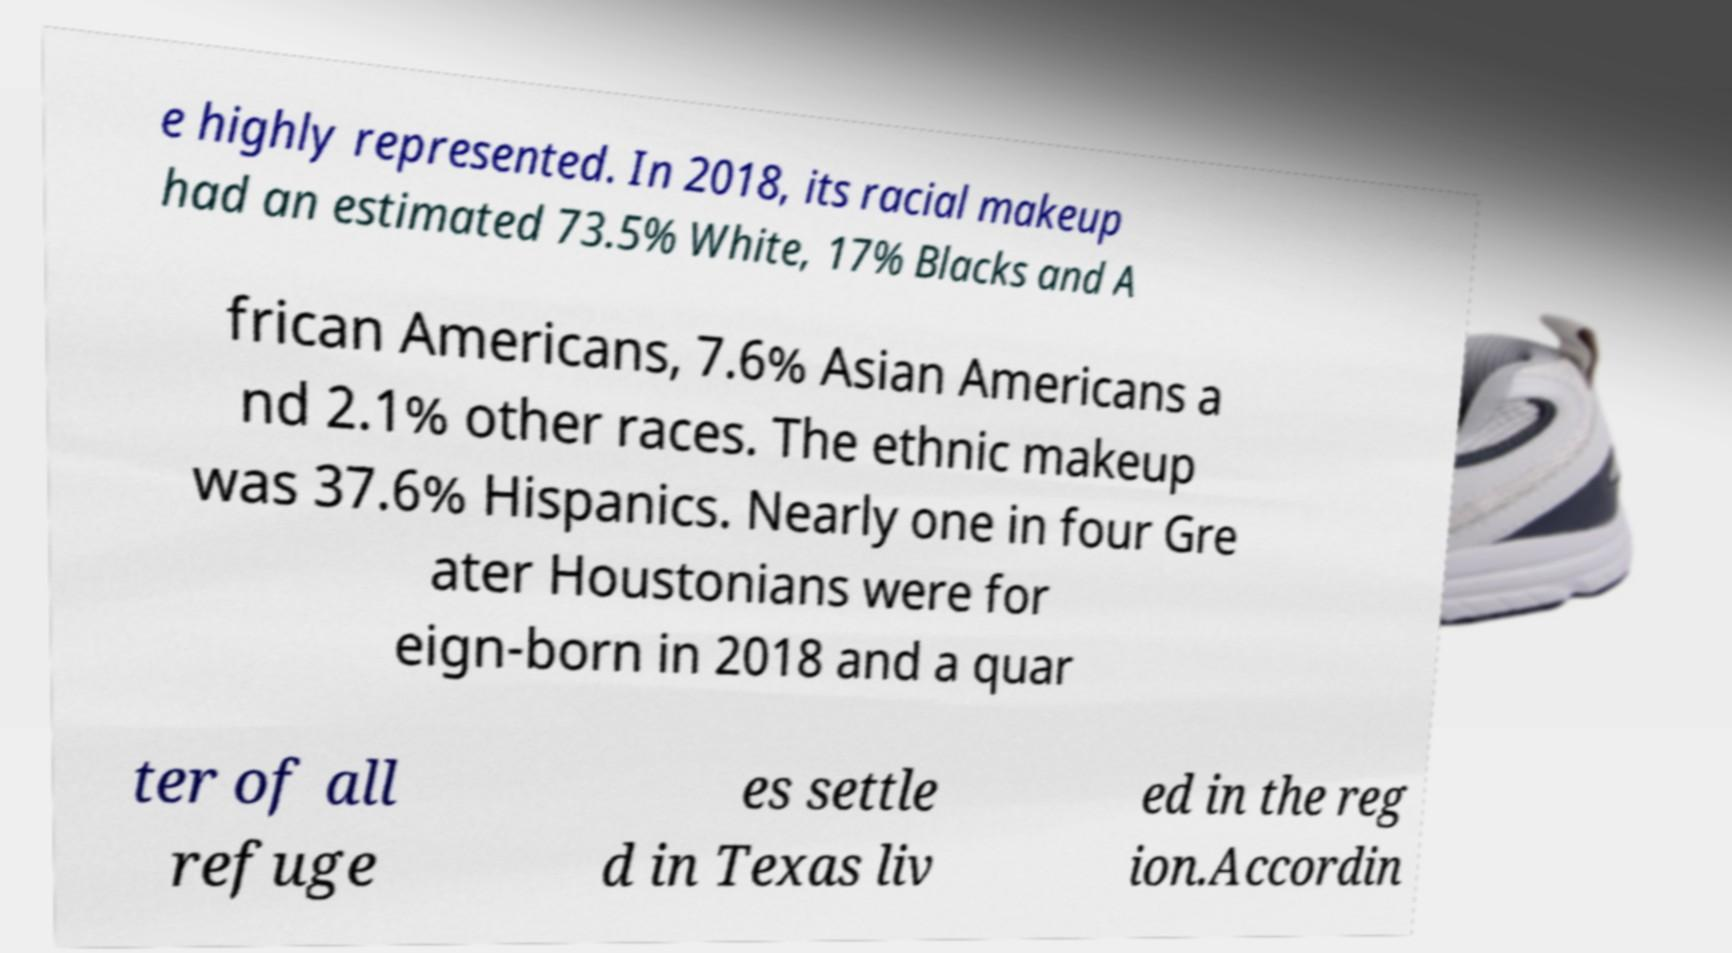What messages or text are displayed in this image? I need them in a readable, typed format. e highly represented. In 2018, its racial makeup had an estimated 73.5% White, 17% Blacks and A frican Americans, 7.6% Asian Americans a nd 2.1% other races. The ethnic makeup was 37.6% Hispanics. Nearly one in four Gre ater Houstonians were for eign-born in 2018 and a quar ter of all refuge es settle d in Texas liv ed in the reg ion.Accordin 